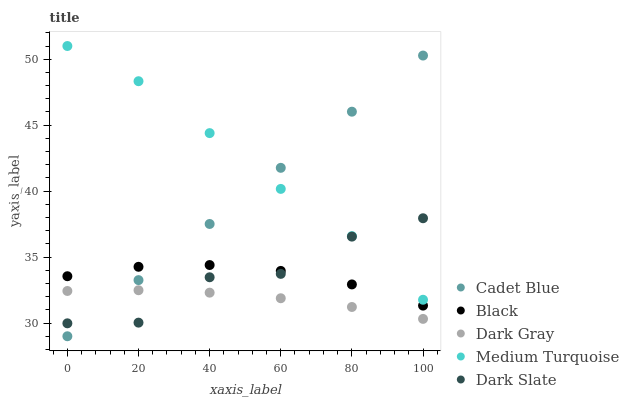Does Dark Gray have the minimum area under the curve?
Answer yes or no. Yes. Does Medium Turquoise have the maximum area under the curve?
Answer yes or no. Yes. Does Dark Slate have the minimum area under the curve?
Answer yes or no. No. Does Dark Slate have the maximum area under the curve?
Answer yes or no. No. Is Cadet Blue the smoothest?
Answer yes or no. Yes. Is Dark Slate the roughest?
Answer yes or no. Yes. Is Dark Slate the smoothest?
Answer yes or no. No. Is Cadet Blue the roughest?
Answer yes or no. No. Does Cadet Blue have the lowest value?
Answer yes or no. Yes. Does Dark Slate have the lowest value?
Answer yes or no. No. Does Medium Turquoise have the highest value?
Answer yes or no. Yes. Does Dark Slate have the highest value?
Answer yes or no. No. Is Black less than Medium Turquoise?
Answer yes or no. Yes. Is Medium Turquoise greater than Black?
Answer yes or no. Yes. Does Cadet Blue intersect Black?
Answer yes or no. Yes. Is Cadet Blue less than Black?
Answer yes or no. No. Is Cadet Blue greater than Black?
Answer yes or no. No. Does Black intersect Medium Turquoise?
Answer yes or no. No. 